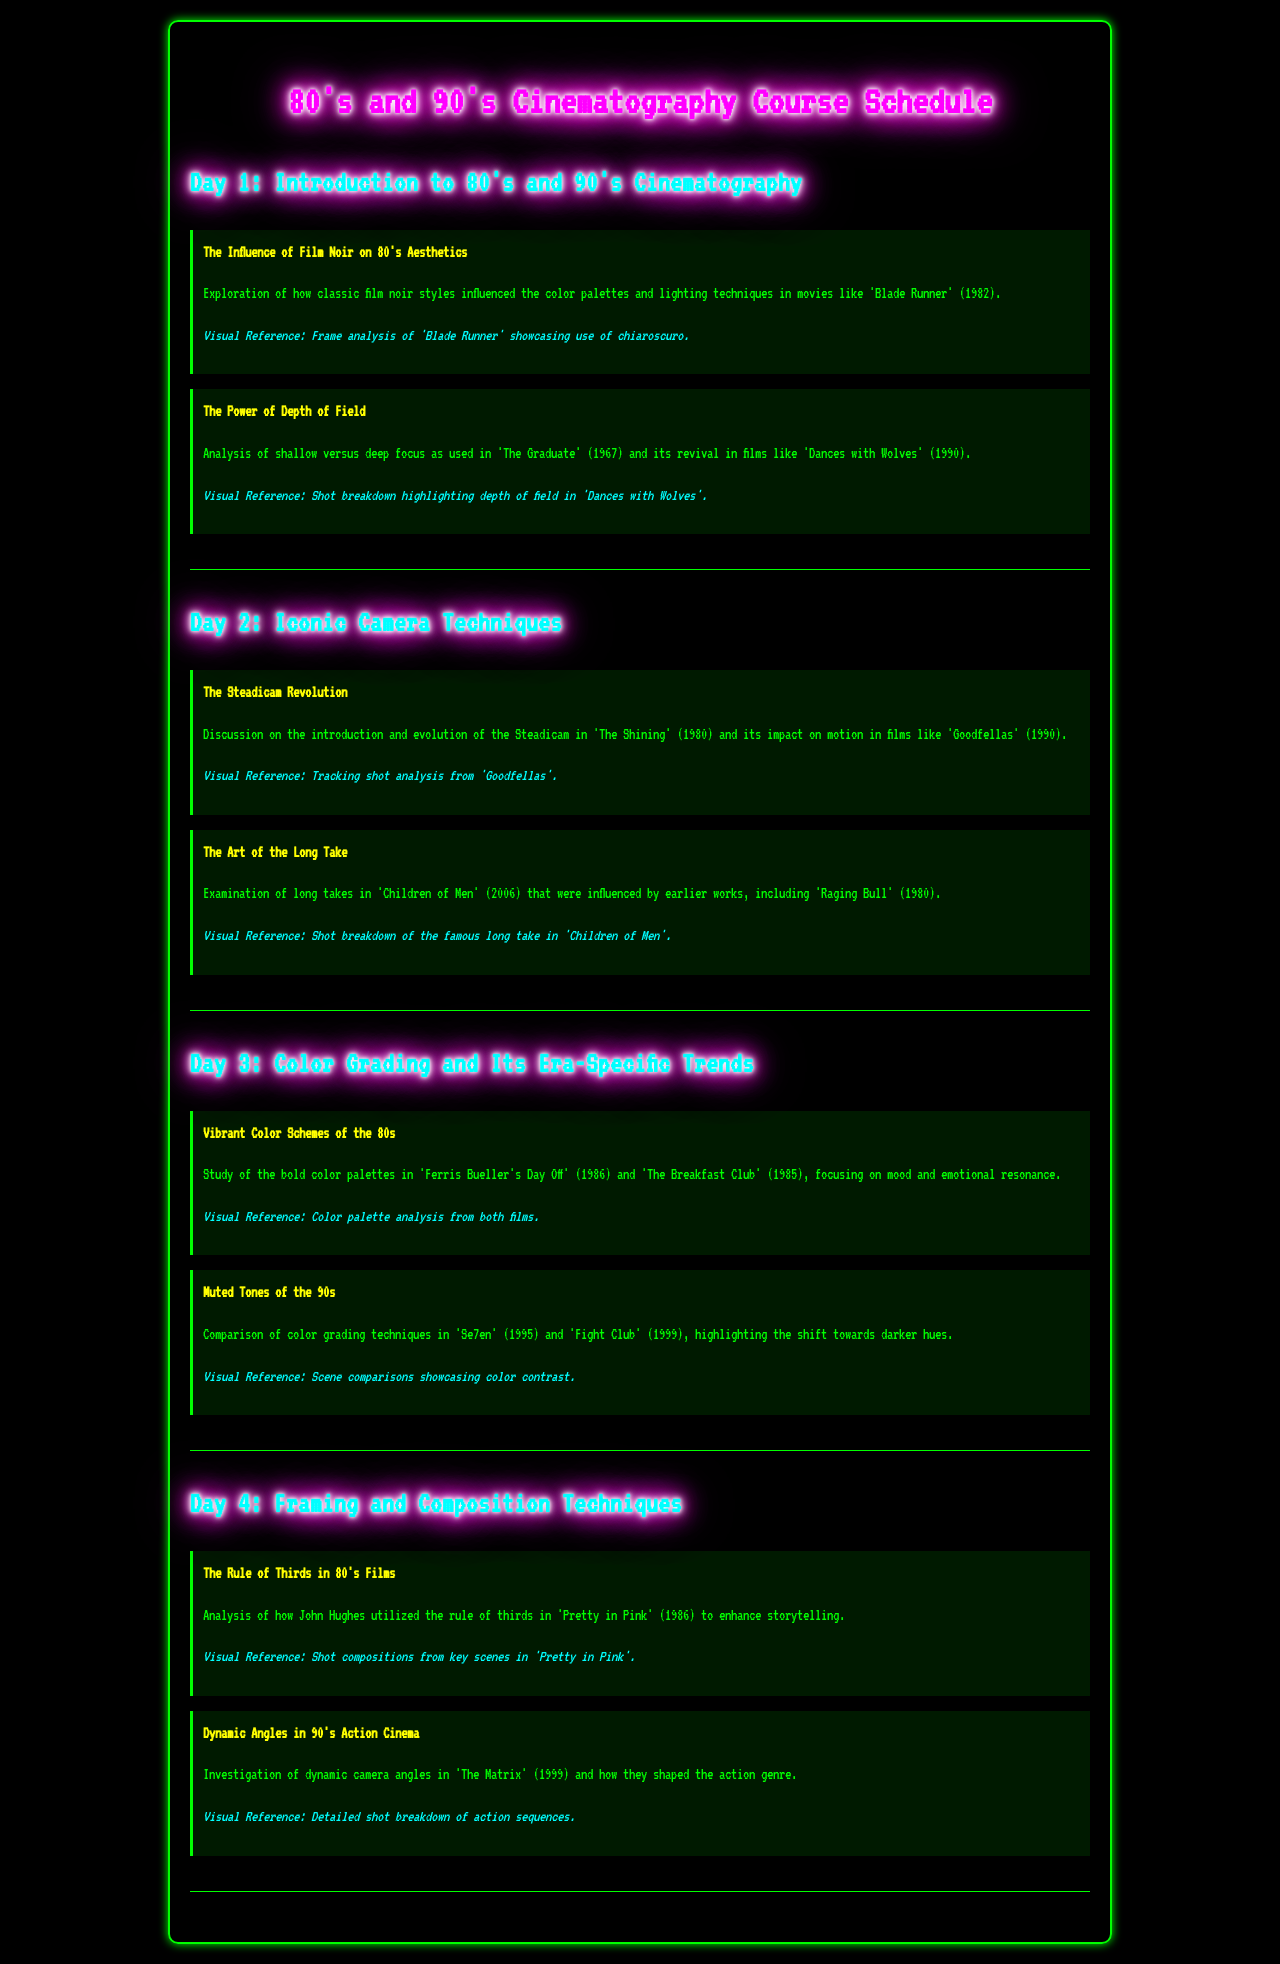what is the title of the course? The title of the course is stated at the top of the document, which is "80's and 90's Cinematography Course Schedule."
Answer: 80's and 90's Cinematography Course Schedule which film is referenced for analyzing depth of field? The document mentions "Dances with Wolves" in the context of depth of field analysis.
Answer: Dances with Wolves how many days does the schedule span? The schedule outlines activities across four distinct days, indicating the total number of days.
Answer: 4 which cinematography technique is discussed on Day 2? The document lists "The Steadicam Revolution" as a topic discussed on Day 2.
Answer: The Steadicam Revolution which film is mentioned in relation to color grading techniques of the 90s? The document refers to "Se7en" when discussing color grading techniques of the 90s.
Answer: Se7en what visual reference is provided for Day 3's first topic? The visual reference for the first topic of Day 3 is a "Color palette analysis from both films."
Answer: Color palette analysis from both films which cinematic rule is explored in "Pretty in Pink"? The document highlights that the "Rule of Thirds" is analyzed in "Pretty in Pink."
Answer: Rule of Thirds what year was "Blade Runner" released? The document states "Blade Runner" was released in 1982, providing the year.
Answer: 1982 what film is used as a reference for the long take examination? The reference for long takes in the document is "Children of Men."
Answer: Children of Men 